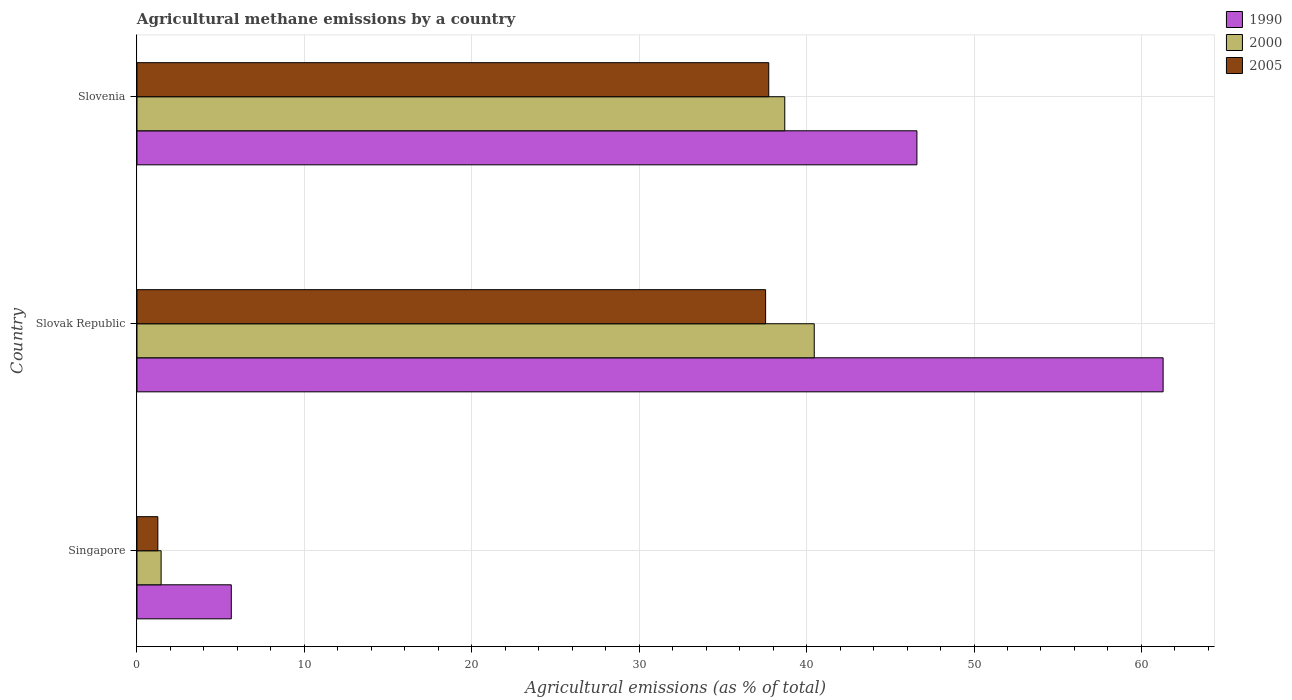How many groups of bars are there?
Provide a short and direct response. 3. Are the number of bars on each tick of the Y-axis equal?
Provide a short and direct response. Yes. What is the label of the 1st group of bars from the top?
Ensure brevity in your answer.  Slovenia. What is the amount of agricultural methane emitted in 2000 in Slovak Republic?
Keep it short and to the point. 40.46. Across all countries, what is the maximum amount of agricultural methane emitted in 1990?
Your answer should be compact. 61.3. Across all countries, what is the minimum amount of agricultural methane emitted in 2005?
Offer a very short reply. 1.25. In which country was the amount of agricultural methane emitted in 1990 maximum?
Keep it short and to the point. Slovak Republic. In which country was the amount of agricultural methane emitted in 1990 minimum?
Provide a succinct answer. Singapore. What is the total amount of agricultural methane emitted in 2005 in the graph?
Your answer should be compact. 76.54. What is the difference between the amount of agricultural methane emitted in 1990 in Singapore and that in Slovenia?
Keep it short and to the point. -40.96. What is the difference between the amount of agricultural methane emitted in 2005 in Slovak Republic and the amount of agricultural methane emitted in 2000 in Singapore?
Give a very brief answer. 36.11. What is the average amount of agricultural methane emitted in 1990 per country?
Offer a terse response. 37.84. What is the difference between the amount of agricultural methane emitted in 2000 and amount of agricultural methane emitted in 2005 in Slovak Republic?
Make the answer very short. 2.91. What is the ratio of the amount of agricultural methane emitted in 2000 in Singapore to that in Slovak Republic?
Your response must be concise. 0.04. Is the amount of agricultural methane emitted in 1990 in Singapore less than that in Slovenia?
Keep it short and to the point. Yes. Is the difference between the amount of agricultural methane emitted in 2000 in Singapore and Slovak Republic greater than the difference between the amount of agricultural methane emitted in 2005 in Singapore and Slovak Republic?
Provide a short and direct response. No. What is the difference between the highest and the second highest amount of agricultural methane emitted in 2000?
Make the answer very short. 1.76. What is the difference between the highest and the lowest amount of agricultural methane emitted in 1990?
Make the answer very short. 55.66. What does the 3rd bar from the top in Singapore represents?
Offer a terse response. 1990. Is it the case that in every country, the sum of the amount of agricultural methane emitted in 1990 and amount of agricultural methane emitted in 2000 is greater than the amount of agricultural methane emitted in 2005?
Your response must be concise. Yes. Are all the bars in the graph horizontal?
Your answer should be compact. Yes. How many countries are there in the graph?
Your response must be concise. 3. What is the difference between two consecutive major ticks on the X-axis?
Provide a succinct answer. 10. Does the graph contain any zero values?
Ensure brevity in your answer.  No. How are the legend labels stacked?
Provide a short and direct response. Vertical. What is the title of the graph?
Give a very brief answer. Agricultural methane emissions by a country. What is the label or title of the X-axis?
Give a very brief answer. Agricultural emissions (as % of total). What is the Agricultural emissions (as % of total) in 1990 in Singapore?
Keep it short and to the point. 5.63. What is the Agricultural emissions (as % of total) in 2000 in Singapore?
Make the answer very short. 1.44. What is the Agricultural emissions (as % of total) in 2005 in Singapore?
Provide a short and direct response. 1.25. What is the Agricultural emissions (as % of total) in 1990 in Slovak Republic?
Your answer should be compact. 61.3. What is the Agricultural emissions (as % of total) of 2000 in Slovak Republic?
Offer a very short reply. 40.46. What is the Agricultural emissions (as % of total) of 2005 in Slovak Republic?
Provide a short and direct response. 37.55. What is the Agricultural emissions (as % of total) of 1990 in Slovenia?
Give a very brief answer. 46.59. What is the Agricultural emissions (as % of total) in 2000 in Slovenia?
Ensure brevity in your answer.  38.7. What is the Agricultural emissions (as % of total) of 2005 in Slovenia?
Your answer should be compact. 37.74. Across all countries, what is the maximum Agricultural emissions (as % of total) in 1990?
Give a very brief answer. 61.3. Across all countries, what is the maximum Agricultural emissions (as % of total) of 2000?
Provide a short and direct response. 40.46. Across all countries, what is the maximum Agricultural emissions (as % of total) of 2005?
Ensure brevity in your answer.  37.74. Across all countries, what is the minimum Agricultural emissions (as % of total) of 1990?
Provide a short and direct response. 5.63. Across all countries, what is the minimum Agricultural emissions (as % of total) in 2000?
Offer a very short reply. 1.44. Across all countries, what is the minimum Agricultural emissions (as % of total) in 2005?
Provide a short and direct response. 1.25. What is the total Agricultural emissions (as % of total) in 1990 in the graph?
Give a very brief answer. 113.52. What is the total Agricultural emissions (as % of total) in 2000 in the graph?
Provide a succinct answer. 80.6. What is the total Agricultural emissions (as % of total) of 2005 in the graph?
Provide a succinct answer. 76.54. What is the difference between the Agricultural emissions (as % of total) in 1990 in Singapore and that in Slovak Republic?
Provide a short and direct response. -55.66. What is the difference between the Agricultural emissions (as % of total) in 2000 in Singapore and that in Slovak Republic?
Provide a succinct answer. -39.01. What is the difference between the Agricultural emissions (as % of total) of 2005 in Singapore and that in Slovak Republic?
Provide a succinct answer. -36.3. What is the difference between the Agricultural emissions (as % of total) in 1990 in Singapore and that in Slovenia?
Offer a terse response. -40.96. What is the difference between the Agricultural emissions (as % of total) of 2000 in Singapore and that in Slovenia?
Offer a very short reply. -37.25. What is the difference between the Agricultural emissions (as % of total) of 2005 in Singapore and that in Slovenia?
Make the answer very short. -36.49. What is the difference between the Agricultural emissions (as % of total) of 1990 in Slovak Republic and that in Slovenia?
Offer a terse response. 14.71. What is the difference between the Agricultural emissions (as % of total) of 2000 in Slovak Republic and that in Slovenia?
Ensure brevity in your answer.  1.76. What is the difference between the Agricultural emissions (as % of total) in 2005 in Slovak Republic and that in Slovenia?
Ensure brevity in your answer.  -0.19. What is the difference between the Agricultural emissions (as % of total) in 1990 in Singapore and the Agricultural emissions (as % of total) in 2000 in Slovak Republic?
Give a very brief answer. -34.82. What is the difference between the Agricultural emissions (as % of total) of 1990 in Singapore and the Agricultural emissions (as % of total) of 2005 in Slovak Republic?
Provide a short and direct response. -31.92. What is the difference between the Agricultural emissions (as % of total) in 2000 in Singapore and the Agricultural emissions (as % of total) in 2005 in Slovak Republic?
Make the answer very short. -36.11. What is the difference between the Agricultural emissions (as % of total) of 1990 in Singapore and the Agricultural emissions (as % of total) of 2000 in Slovenia?
Make the answer very short. -33.06. What is the difference between the Agricultural emissions (as % of total) of 1990 in Singapore and the Agricultural emissions (as % of total) of 2005 in Slovenia?
Your answer should be compact. -32.1. What is the difference between the Agricultural emissions (as % of total) of 2000 in Singapore and the Agricultural emissions (as % of total) of 2005 in Slovenia?
Provide a succinct answer. -36.3. What is the difference between the Agricultural emissions (as % of total) of 1990 in Slovak Republic and the Agricultural emissions (as % of total) of 2000 in Slovenia?
Your response must be concise. 22.6. What is the difference between the Agricultural emissions (as % of total) in 1990 in Slovak Republic and the Agricultural emissions (as % of total) in 2005 in Slovenia?
Make the answer very short. 23.56. What is the difference between the Agricultural emissions (as % of total) of 2000 in Slovak Republic and the Agricultural emissions (as % of total) of 2005 in Slovenia?
Your answer should be compact. 2.72. What is the average Agricultural emissions (as % of total) in 1990 per country?
Provide a succinct answer. 37.84. What is the average Agricultural emissions (as % of total) in 2000 per country?
Give a very brief answer. 26.87. What is the average Agricultural emissions (as % of total) of 2005 per country?
Ensure brevity in your answer.  25.51. What is the difference between the Agricultural emissions (as % of total) of 1990 and Agricultural emissions (as % of total) of 2000 in Singapore?
Provide a short and direct response. 4.19. What is the difference between the Agricultural emissions (as % of total) of 1990 and Agricultural emissions (as % of total) of 2005 in Singapore?
Your response must be concise. 4.39. What is the difference between the Agricultural emissions (as % of total) of 2000 and Agricultural emissions (as % of total) of 2005 in Singapore?
Provide a short and direct response. 0.2. What is the difference between the Agricultural emissions (as % of total) in 1990 and Agricultural emissions (as % of total) in 2000 in Slovak Republic?
Provide a succinct answer. 20.84. What is the difference between the Agricultural emissions (as % of total) in 1990 and Agricultural emissions (as % of total) in 2005 in Slovak Republic?
Your answer should be very brief. 23.75. What is the difference between the Agricultural emissions (as % of total) in 2000 and Agricultural emissions (as % of total) in 2005 in Slovak Republic?
Keep it short and to the point. 2.91. What is the difference between the Agricultural emissions (as % of total) of 1990 and Agricultural emissions (as % of total) of 2000 in Slovenia?
Provide a short and direct response. 7.89. What is the difference between the Agricultural emissions (as % of total) in 1990 and Agricultural emissions (as % of total) in 2005 in Slovenia?
Ensure brevity in your answer.  8.85. What is the difference between the Agricultural emissions (as % of total) of 2000 and Agricultural emissions (as % of total) of 2005 in Slovenia?
Give a very brief answer. 0.96. What is the ratio of the Agricultural emissions (as % of total) of 1990 in Singapore to that in Slovak Republic?
Your answer should be very brief. 0.09. What is the ratio of the Agricultural emissions (as % of total) of 2000 in Singapore to that in Slovak Republic?
Keep it short and to the point. 0.04. What is the ratio of the Agricultural emissions (as % of total) in 2005 in Singapore to that in Slovak Republic?
Your answer should be compact. 0.03. What is the ratio of the Agricultural emissions (as % of total) of 1990 in Singapore to that in Slovenia?
Your answer should be very brief. 0.12. What is the ratio of the Agricultural emissions (as % of total) in 2000 in Singapore to that in Slovenia?
Keep it short and to the point. 0.04. What is the ratio of the Agricultural emissions (as % of total) of 2005 in Singapore to that in Slovenia?
Offer a terse response. 0.03. What is the ratio of the Agricultural emissions (as % of total) of 1990 in Slovak Republic to that in Slovenia?
Keep it short and to the point. 1.32. What is the ratio of the Agricultural emissions (as % of total) of 2000 in Slovak Republic to that in Slovenia?
Provide a succinct answer. 1.05. What is the difference between the highest and the second highest Agricultural emissions (as % of total) of 1990?
Ensure brevity in your answer.  14.71. What is the difference between the highest and the second highest Agricultural emissions (as % of total) of 2000?
Offer a very short reply. 1.76. What is the difference between the highest and the second highest Agricultural emissions (as % of total) of 2005?
Make the answer very short. 0.19. What is the difference between the highest and the lowest Agricultural emissions (as % of total) of 1990?
Keep it short and to the point. 55.66. What is the difference between the highest and the lowest Agricultural emissions (as % of total) of 2000?
Offer a terse response. 39.01. What is the difference between the highest and the lowest Agricultural emissions (as % of total) in 2005?
Ensure brevity in your answer.  36.49. 